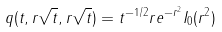<formula> <loc_0><loc_0><loc_500><loc_500>q ( t , r \sqrt { t } , r \sqrt { t } ) = t ^ { - 1 / 2 } r e ^ { - r ^ { 2 } } I _ { 0 } ( r ^ { 2 } )</formula> 